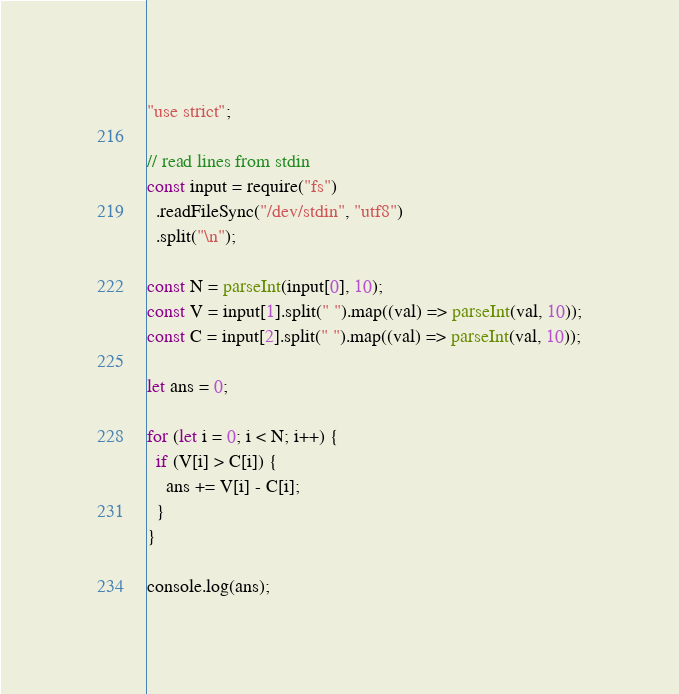Convert code to text. <code><loc_0><loc_0><loc_500><loc_500><_JavaScript_>"use strict";

// read lines from stdin
const input = require("fs")
  .readFileSync("/dev/stdin", "utf8")
  .split("\n");

const N = parseInt(input[0], 10);
const V = input[1].split(" ").map((val) => parseInt(val, 10));
const C = input[2].split(" ").map((val) => parseInt(val, 10));

let ans = 0;

for (let i = 0; i < N; i++) {
  if (V[i] > C[i]) {
    ans += V[i] - C[i];
  }
}

console.log(ans);</code> 